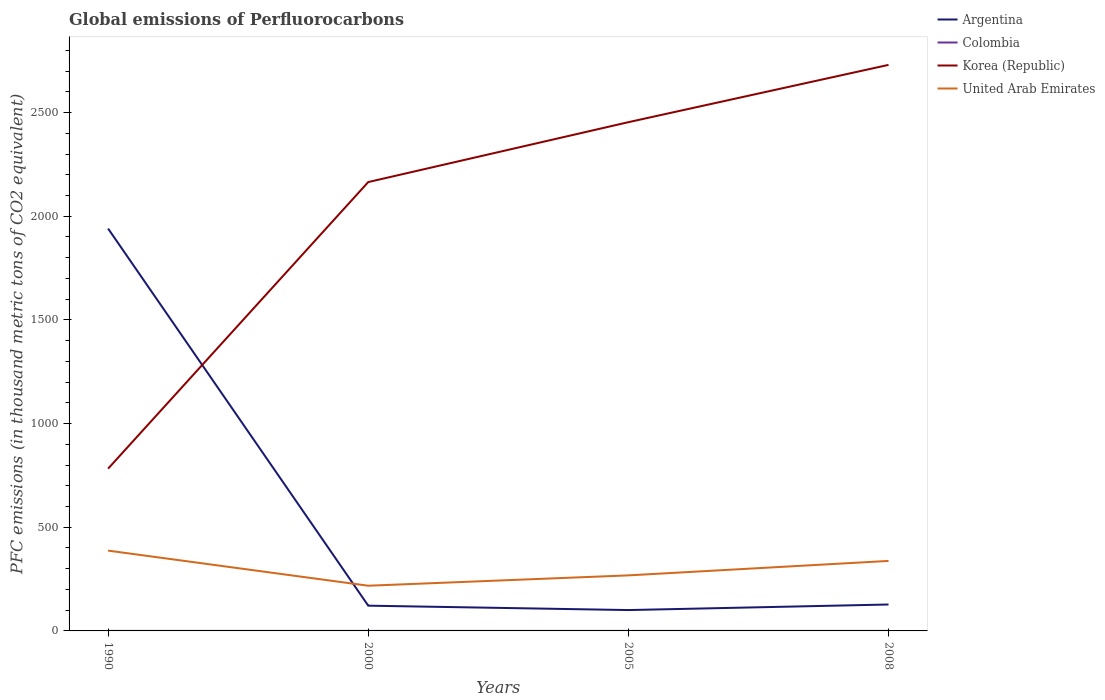Across all years, what is the maximum global emissions of Perfluorocarbons in Korea (Republic)?
Keep it short and to the point. 782.6. In which year was the global emissions of Perfluorocarbons in Korea (Republic) maximum?
Give a very brief answer. 1990. What is the total global emissions of Perfluorocarbons in Argentina in the graph?
Provide a succinct answer. 1818.8. What is the difference between the highest and the second highest global emissions of Perfluorocarbons in United Arab Emirates?
Offer a terse response. 169.3. Is the global emissions of Perfluorocarbons in Korea (Republic) strictly greater than the global emissions of Perfluorocarbons in United Arab Emirates over the years?
Keep it short and to the point. No. Are the values on the major ticks of Y-axis written in scientific E-notation?
Ensure brevity in your answer.  No. Does the graph contain any zero values?
Your answer should be very brief. No. What is the title of the graph?
Provide a succinct answer. Global emissions of Perfluorocarbons. What is the label or title of the X-axis?
Give a very brief answer. Years. What is the label or title of the Y-axis?
Your answer should be compact. PFC emissions (in thousand metric tons of CO2 equivalent). What is the PFC emissions (in thousand metric tons of CO2 equivalent) in Argentina in 1990?
Your response must be concise. 1940.6. What is the PFC emissions (in thousand metric tons of CO2 equivalent) of Colombia in 1990?
Give a very brief answer. 0.2. What is the PFC emissions (in thousand metric tons of CO2 equivalent) in Korea (Republic) in 1990?
Keep it short and to the point. 782.6. What is the PFC emissions (in thousand metric tons of CO2 equivalent) of United Arab Emirates in 1990?
Your response must be concise. 387.3. What is the PFC emissions (in thousand metric tons of CO2 equivalent) in Argentina in 2000?
Your response must be concise. 121.8. What is the PFC emissions (in thousand metric tons of CO2 equivalent) in Colombia in 2000?
Make the answer very short. 0.2. What is the PFC emissions (in thousand metric tons of CO2 equivalent) of Korea (Republic) in 2000?
Your response must be concise. 2164.9. What is the PFC emissions (in thousand metric tons of CO2 equivalent) of United Arab Emirates in 2000?
Give a very brief answer. 218. What is the PFC emissions (in thousand metric tons of CO2 equivalent) in Argentina in 2005?
Ensure brevity in your answer.  100.6. What is the PFC emissions (in thousand metric tons of CO2 equivalent) of Colombia in 2005?
Make the answer very short. 0.2. What is the PFC emissions (in thousand metric tons of CO2 equivalent) of Korea (Republic) in 2005?
Make the answer very short. 2453.7. What is the PFC emissions (in thousand metric tons of CO2 equivalent) of United Arab Emirates in 2005?
Keep it short and to the point. 267.9. What is the PFC emissions (in thousand metric tons of CO2 equivalent) in Argentina in 2008?
Offer a very short reply. 127.4. What is the PFC emissions (in thousand metric tons of CO2 equivalent) in Korea (Republic) in 2008?
Make the answer very short. 2730.1. What is the PFC emissions (in thousand metric tons of CO2 equivalent) of United Arab Emirates in 2008?
Provide a succinct answer. 337.6. Across all years, what is the maximum PFC emissions (in thousand metric tons of CO2 equivalent) in Argentina?
Provide a short and direct response. 1940.6. Across all years, what is the maximum PFC emissions (in thousand metric tons of CO2 equivalent) of Colombia?
Provide a short and direct response. 0.2. Across all years, what is the maximum PFC emissions (in thousand metric tons of CO2 equivalent) of Korea (Republic)?
Provide a short and direct response. 2730.1. Across all years, what is the maximum PFC emissions (in thousand metric tons of CO2 equivalent) of United Arab Emirates?
Offer a terse response. 387.3. Across all years, what is the minimum PFC emissions (in thousand metric tons of CO2 equivalent) of Argentina?
Your answer should be compact. 100.6. Across all years, what is the minimum PFC emissions (in thousand metric tons of CO2 equivalent) in Colombia?
Ensure brevity in your answer.  0.2. Across all years, what is the minimum PFC emissions (in thousand metric tons of CO2 equivalent) in Korea (Republic)?
Offer a very short reply. 782.6. Across all years, what is the minimum PFC emissions (in thousand metric tons of CO2 equivalent) of United Arab Emirates?
Make the answer very short. 218. What is the total PFC emissions (in thousand metric tons of CO2 equivalent) in Argentina in the graph?
Your answer should be compact. 2290.4. What is the total PFC emissions (in thousand metric tons of CO2 equivalent) in Colombia in the graph?
Offer a very short reply. 0.8. What is the total PFC emissions (in thousand metric tons of CO2 equivalent) in Korea (Republic) in the graph?
Keep it short and to the point. 8131.3. What is the total PFC emissions (in thousand metric tons of CO2 equivalent) of United Arab Emirates in the graph?
Your response must be concise. 1210.8. What is the difference between the PFC emissions (in thousand metric tons of CO2 equivalent) in Argentina in 1990 and that in 2000?
Your response must be concise. 1818.8. What is the difference between the PFC emissions (in thousand metric tons of CO2 equivalent) in Colombia in 1990 and that in 2000?
Offer a very short reply. 0. What is the difference between the PFC emissions (in thousand metric tons of CO2 equivalent) in Korea (Republic) in 1990 and that in 2000?
Your response must be concise. -1382.3. What is the difference between the PFC emissions (in thousand metric tons of CO2 equivalent) in United Arab Emirates in 1990 and that in 2000?
Provide a succinct answer. 169.3. What is the difference between the PFC emissions (in thousand metric tons of CO2 equivalent) of Argentina in 1990 and that in 2005?
Your response must be concise. 1840. What is the difference between the PFC emissions (in thousand metric tons of CO2 equivalent) of Korea (Republic) in 1990 and that in 2005?
Give a very brief answer. -1671.1. What is the difference between the PFC emissions (in thousand metric tons of CO2 equivalent) of United Arab Emirates in 1990 and that in 2005?
Offer a very short reply. 119.4. What is the difference between the PFC emissions (in thousand metric tons of CO2 equivalent) in Argentina in 1990 and that in 2008?
Ensure brevity in your answer.  1813.2. What is the difference between the PFC emissions (in thousand metric tons of CO2 equivalent) in Korea (Republic) in 1990 and that in 2008?
Your answer should be compact. -1947.5. What is the difference between the PFC emissions (in thousand metric tons of CO2 equivalent) of United Arab Emirates in 1990 and that in 2008?
Keep it short and to the point. 49.7. What is the difference between the PFC emissions (in thousand metric tons of CO2 equivalent) of Argentina in 2000 and that in 2005?
Your answer should be very brief. 21.2. What is the difference between the PFC emissions (in thousand metric tons of CO2 equivalent) in Korea (Republic) in 2000 and that in 2005?
Give a very brief answer. -288.8. What is the difference between the PFC emissions (in thousand metric tons of CO2 equivalent) in United Arab Emirates in 2000 and that in 2005?
Keep it short and to the point. -49.9. What is the difference between the PFC emissions (in thousand metric tons of CO2 equivalent) in Colombia in 2000 and that in 2008?
Provide a succinct answer. 0. What is the difference between the PFC emissions (in thousand metric tons of CO2 equivalent) of Korea (Republic) in 2000 and that in 2008?
Keep it short and to the point. -565.2. What is the difference between the PFC emissions (in thousand metric tons of CO2 equivalent) in United Arab Emirates in 2000 and that in 2008?
Make the answer very short. -119.6. What is the difference between the PFC emissions (in thousand metric tons of CO2 equivalent) of Argentina in 2005 and that in 2008?
Provide a succinct answer. -26.8. What is the difference between the PFC emissions (in thousand metric tons of CO2 equivalent) in Colombia in 2005 and that in 2008?
Provide a short and direct response. 0. What is the difference between the PFC emissions (in thousand metric tons of CO2 equivalent) in Korea (Republic) in 2005 and that in 2008?
Offer a very short reply. -276.4. What is the difference between the PFC emissions (in thousand metric tons of CO2 equivalent) of United Arab Emirates in 2005 and that in 2008?
Keep it short and to the point. -69.7. What is the difference between the PFC emissions (in thousand metric tons of CO2 equivalent) of Argentina in 1990 and the PFC emissions (in thousand metric tons of CO2 equivalent) of Colombia in 2000?
Your answer should be very brief. 1940.4. What is the difference between the PFC emissions (in thousand metric tons of CO2 equivalent) of Argentina in 1990 and the PFC emissions (in thousand metric tons of CO2 equivalent) of Korea (Republic) in 2000?
Your response must be concise. -224.3. What is the difference between the PFC emissions (in thousand metric tons of CO2 equivalent) in Argentina in 1990 and the PFC emissions (in thousand metric tons of CO2 equivalent) in United Arab Emirates in 2000?
Your response must be concise. 1722.6. What is the difference between the PFC emissions (in thousand metric tons of CO2 equivalent) of Colombia in 1990 and the PFC emissions (in thousand metric tons of CO2 equivalent) of Korea (Republic) in 2000?
Ensure brevity in your answer.  -2164.7. What is the difference between the PFC emissions (in thousand metric tons of CO2 equivalent) of Colombia in 1990 and the PFC emissions (in thousand metric tons of CO2 equivalent) of United Arab Emirates in 2000?
Provide a succinct answer. -217.8. What is the difference between the PFC emissions (in thousand metric tons of CO2 equivalent) in Korea (Republic) in 1990 and the PFC emissions (in thousand metric tons of CO2 equivalent) in United Arab Emirates in 2000?
Give a very brief answer. 564.6. What is the difference between the PFC emissions (in thousand metric tons of CO2 equivalent) of Argentina in 1990 and the PFC emissions (in thousand metric tons of CO2 equivalent) of Colombia in 2005?
Keep it short and to the point. 1940.4. What is the difference between the PFC emissions (in thousand metric tons of CO2 equivalent) of Argentina in 1990 and the PFC emissions (in thousand metric tons of CO2 equivalent) of Korea (Republic) in 2005?
Ensure brevity in your answer.  -513.1. What is the difference between the PFC emissions (in thousand metric tons of CO2 equivalent) in Argentina in 1990 and the PFC emissions (in thousand metric tons of CO2 equivalent) in United Arab Emirates in 2005?
Offer a very short reply. 1672.7. What is the difference between the PFC emissions (in thousand metric tons of CO2 equivalent) of Colombia in 1990 and the PFC emissions (in thousand metric tons of CO2 equivalent) of Korea (Republic) in 2005?
Provide a short and direct response. -2453.5. What is the difference between the PFC emissions (in thousand metric tons of CO2 equivalent) in Colombia in 1990 and the PFC emissions (in thousand metric tons of CO2 equivalent) in United Arab Emirates in 2005?
Your answer should be compact. -267.7. What is the difference between the PFC emissions (in thousand metric tons of CO2 equivalent) in Korea (Republic) in 1990 and the PFC emissions (in thousand metric tons of CO2 equivalent) in United Arab Emirates in 2005?
Provide a short and direct response. 514.7. What is the difference between the PFC emissions (in thousand metric tons of CO2 equivalent) in Argentina in 1990 and the PFC emissions (in thousand metric tons of CO2 equivalent) in Colombia in 2008?
Offer a very short reply. 1940.4. What is the difference between the PFC emissions (in thousand metric tons of CO2 equivalent) of Argentina in 1990 and the PFC emissions (in thousand metric tons of CO2 equivalent) of Korea (Republic) in 2008?
Ensure brevity in your answer.  -789.5. What is the difference between the PFC emissions (in thousand metric tons of CO2 equivalent) in Argentina in 1990 and the PFC emissions (in thousand metric tons of CO2 equivalent) in United Arab Emirates in 2008?
Offer a terse response. 1603. What is the difference between the PFC emissions (in thousand metric tons of CO2 equivalent) in Colombia in 1990 and the PFC emissions (in thousand metric tons of CO2 equivalent) in Korea (Republic) in 2008?
Your response must be concise. -2729.9. What is the difference between the PFC emissions (in thousand metric tons of CO2 equivalent) in Colombia in 1990 and the PFC emissions (in thousand metric tons of CO2 equivalent) in United Arab Emirates in 2008?
Offer a terse response. -337.4. What is the difference between the PFC emissions (in thousand metric tons of CO2 equivalent) in Korea (Republic) in 1990 and the PFC emissions (in thousand metric tons of CO2 equivalent) in United Arab Emirates in 2008?
Give a very brief answer. 445. What is the difference between the PFC emissions (in thousand metric tons of CO2 equivalent) of Argentina in 2000 and the PFC emissions (in thousand metric tons of CO2 equivalent) of Colombia in 2005?
Make the answer very short. 121.6. What is the difference between the PFC emissions (in thousand metric tons of CO2 equivalent) of Argentina in 2000 and the PFC emissions (in thousand metric tons of CO2 equivalent) of Korea (Republic) in 2005?
Offer a very short reply. -2331.9. What is the difference between the PFC emissions (in thousand metric tons of CO2 equivalent) in Argentina in 2000 and the PFC emissions (in thousand metric tons of CO2 equivalent) in United Arab Emirates in 2005?
Provide a short and direct response. -146.1. What is the difference between the PFC emissions (in thousand metric tons of CO2 equivalent) in Colombia in 2000 and the PFC emissions (in thousand metric tons of CO2 equivalent) in Korea (Republic) in 2005?
Your response must be concise. -2453.5. What is the difference between the PFC emissions (in thousand metric tons of CO2 equivalent) in Colombia in 2000 and the PFC emissions (in thousand metric tons of CO2 equivalent) in United Arab Emirates in 2005?
Offer a very short reply. -267.7. What is the difference between the PFC emissions (in thousand metric tons of CO2 equivalent) in Korea (Republic) in 2000 and the PFC emissions (in thousand metric tons of CO2 equivalent) in United Arab Emirates in 2005?
Give a very brief answer. 1897. What is the difference between the PFC emissions (in thousand metric tons of CO2 equivalent) in Argentina in 2000 and the PFC emissions (in thousand metric tons of CO2 equivalent) in Colombia in 2008?
Your answer should be compact. 121.6. What is the difference between the PFC emissions (in thousand metric tons of CO2 equivalent) of Argentina in 2000 and the PFC emissions (in thousand metric tons of CO2 equivalent) of Korea (Republic) in 2008?
Provide a succinct answer. -2608.3. What is the difference between the PFC emissions (in thousand metric tons of CO2 equivalent) in Argentina in 2000 and the PFC emissions (in thousand metric tons of CO2 equivalent) in United Arab Emirates in 2008?
Make the answer very short. -215.8. What is the difference between the PFC emissions (in thousand metric tons of CO2 equivalent) in Colombia in 2000 and the PFC emissions (in thousand metric tons of CO2 equivalent) in Korea (Republic) in 2008?
Provide a short and direct response. -2729.9. What is the difference between the PFC emissions (in thousand metric tons of CO2 equivalent) in Colombia in 2000 and the PFC emissions (in thousand metric tons of CO2 equivalent) in United Arab Emirates in 2008?
Make the answer very short. -337.4. What is the difference between the PFC emissions (in thousand metric tons of CO2 equivalent) in Korea (Republic) in 2000 and the PFC emissions (in thousand metric tons of CO2 equivalent) in United Arab Emirates in 2008?
Provide a succinct answer. 1827.3. What is the difference between the PFC emissions (in thousand metric tons of CO2 equivalent) in Argentina in 2005 and the PFC emissions (in thousand metric tons of CO2 equivalent) in Colombia in 2008?
Provide a succinct answer. 100.4. What is the difference between the PFC emissions (in thousand metric tons of CO2 equivalent) in Argentina in 2005 and the PFC emissions (in thousand metric tons of CO2 equivalent) in Korea (Republic) in 2008?
Offer a terse response. -2629.5. What is the difference between the PFC emissions (in thousand metric tons of CO2 equivalent) of Argentina in 2005 and the PFC emissions (in thousand metric tons of CO2 equivalent) of United Arab Emirates in 2008?
Offer a terse response. -237. What is the difference between the PFC emissions (in thousand metric tons of CO2 equivalent) in Colombia in 2005 and the PFC emissions (in thousand metric tons of CO2 equivalent) in Korea (Republic) in 2008?
Make the answer very short. -2729.9. What is the difference between the PFC emissions (in thousand metric tons of CO2 equivalent) of Colombia in 2005 and the PFC emissions (in thousand metric tons of CO2 equivalent) of United Arab Emirates in 2008?
Your response must be concise. -337.4. What is the difference between the PFC emissions (in thousand metric tons of CO2 equivalent) of Korea (Republic) in 2005 and the PFC emissions (in thousand metric tons of CO2 equivalent) of United Arab Emirates in 2008?
Your response must be concise. 2116.1. What is the average PFC emissions (in thousand metric tons of CO2 equivalent) in Argentina per year?
Provide a succinct answer. 572.6. What is the average PFC emissions (in thousand metric tons of CO2 equivalent) of Colombia per year?
Ensure brevity in your answer.  0.2. What is the average PFC emissions (in thousand metric tons of CO2 equivalent) in Korea (Republic) per year?
Make the answer very short. 2032.83. What is the average PFC emissions (in thousand metric tons of CO2 equivalent) of United Arab Emirates per year?
Provide a succinct answer. 302.7. In the year 1990, what is the difference between the PFC emissions (in thousand metric tons of CO2 equivalent) in Argentina and PFC emissions (in thousand metric tons of CO2 equivalent) in Colombia?
Give a very brief answer. 1940.4. In the year 1990, what is the difference between the PFC emissions (in thousand metric tons of CO2 equivalent) in Argentina and PFC emissions (in thousand metric tons of CO2 equivalent) in Korea (Republic)?
Provide a short and direct response. 1158. In the year 1990, what is the difference between the PFC emissions (in thousand metric tons of CO2 equivalent) of Argentina and PFC emissions (in thousand metric tons of CO2 equivalent) of United Arab Emirates?
Make the answer very short. 1553.3. In the year 1990, what is the difference between the PFC emissions (in thousand metric tons of CO2 equivalent) of Colombia and PFC emissions (in thousand metric tons of CO2 equivalent) of Korea (Republic)?
Offer a very short reply. -782.4. In the year 1990, what is the difference between the PFC emissions (in thousand metric tons of CO2 equivalent) in Colombia and PFC emissions (in thousand metric tons of CO2 equivalent) in United Arab Emirates?
Make the answer very short. -387.1. In the year 1990, what is the difference between the PFC emissions (in thousand metric tons of CO2 equivalent) in Korea (Republic) and PFC emissions (in thousand metric tons of CO2 equivalent) in United Arab Emirates?
Your response must be concise. 395.3. In the year 2000, what is the difference between the PFC emissions (in thousand metric tons of CO2 equivalent) of Argentina and PFC emissions (in thousand metric tons of CO2 equivalent) of Colombia?
Your response must be concise. 121.6. In the year 2000, what is the difference between the PFC emissions (in thousand metric tons of CO2 equivalent) in Argentina and PFC emissions (in thousand metric tons of CO2 equivalent) in Korea (Republic)?
Provide a short and direct response. -2043.1. In the year 2000, what is the difference between the PFC emissions (in thousand metric tons of CO2 equivalent) in Argentina and PFC emissions (in thousand metric tons of CO2 equivalent) in United Arab Emirates?
Keep it short and to the point. -96.2. In the year 2000, what is the difference between the PFC emissions (in thousand metric tons of CO2 equivalent) of Colombia and PFC emissions (in thousand metric tons of CO2 equivalent) of Korea (Republic)?
Make the answer very short. -2164.7. In the year 2000, what is the difference between the PFC emissions (in thousand metric tons of CO2 equivalent) of Colombia and PFC emissions (in thousand metric tons of CO2 equivalent) of United Arab Emirates?
Make the answer very short. -217.8. In the year 2000, what is the difference between the PFC emissions (in thousand metric tons of CO2 equivalent) in Korea (Republic) and PFC emissions (in thousand metric tons of CO2 equivalent) in United Arab Emirates?
Offer a very short reply. 1946.9. In the year 2005, what is the difference between the PFC emissions (in thousand metric tons of CO2 equivalent) of Argentina and PFC emissions (in thousand metric tons of CO2 equivalent) of Colombia?
Your response must be concise. 100.4. In the year 2005, what is the difference between the PFC emissions (in thousand metric tons of CO2 equivalent) of Argentina and PFC emissions (in thousand metric tons of CO2 equivalent) of Korea (Republic)?
Offer a terse response. -2353.1. In the year 2005, what is the difference between the PFC emissions (in thousand metric tons of CO2 equivalent) of Argentina and PFC emissions (in thousand metric tons of CO2 equivalent) of United Arab Emirates?
Give a very brief answer. -167.3. In the year 2005, what is the difference between the PFC emissions (in thousand metric tons of CO2 equivalent) of Colombia and PFC emissions (in thousand metric tons of CO2 equivalent) of Korea (Republic)?
Your response must be concise. -2453.5. In the year 2005, what is the difference between the PFC emissions (in thousand metric tons of CO2 equivalent) of Colombia and PFC emissions (in thousand metric tons of CO2 equivalent) of United Arab Emirates?
Your response must be concise. -267.7. In the year 2005, what is the difference between the PFC emissions (in thousand metric tons of CO2 equivalent) in Korea (Republic) and PFC emissions (in thousand metric tons of CO2 equivalent) in United Arab Emirates?
Give a very brief answer. 2185.8. In the year 2008, what is the difference between the PFC emissions (in thousand metric tons of CO2 equivalent) of Argentina and PFC emissions (in thousand metric tons of CO2 equivalent) of Colombia?
Your answer should be very brief. 127.2. In the year 2008, what is the difference between the PFC emissions (in thousand metric tons of CO2 equivalent) of Argentina and PFC emissions (in thousand metric tons of CO2 equivalent) of Korea (Republic)?
Ensure brevity in your answer.  -2602.7. In the year 2008, what is the difference between the PFC emissions (in thousand metric tons of CO2 equivalent) in Argentina and PFC emissions (in thousand metric tons of CO2 equivalent) in United Arab Emirates?
Provide a succinct answer. -210.2. In the year 2008, what is the difference between the PFC emissions (in thousand metric tons of CO2 equivalent) of Colombia and PFC emissions (in thousand metric tons of CO2 equivalent) of Korea (Republic)?
Provide a succinct answer. -2729.9. In the year 2008, what is the difference between the PFC emissions (in thousand metric tons of CO2 equivalent) in Colombia and PFC emissions (in thousand metric tons of CO2 equivalent) in United Arab Emirates?
Provide a succinct answer. -337.4. In the year 2008, what is the difference between the PFC emissions (in thousand metric tons of CO2 equivalent) of Korea (Republic) and PFC emissions (in thousand metric tons of CO2 equivalent) of United Arab Emirates?
Your response must be concise. 2392.5. What is the ratio of the PFC emissions (in thousand metric tons of CO2 equivalent) in Argentina in 1990 to that in 2000?
Provide a succinct answer. 15.93. What is the ratio of the PFC emissions (in thousand metric tons of CO2 equivalent) of Colombia in 1990 to that in 2000?
Ensure brevity in your answer.  1. What is the ratio of the PFC emissions (in thousand metric tons of CO2 equivalent) in Korea (Republic) in 1990 to that in 2000?
Your response must be concise. 0.36. What is the ratio of the PFC emissions (in thousand metric tons of CO2 equivalent) of United Arab Emirates in 1990 to that in 2000?
Provide a succinct answer. 1.78. What is the ratio of the PFC emissions (in thousand metric tons of CO2 equivalent) in Argentina in 1990 to that in 2005?
Keep it short and to the point. 19.29. What is the ratio of the PFC emissions (in thousand metric tons of CO2 equivalent) of Colombia in 1990 to that in 2005?
Your answer should be very brief. 1. What is the ratio of the PFC emissions (in thousand metric tons of CO2 equivalent) of Korea (Republic) in 1990 to that in 2005?
Your answer should be compact. 0.32. What is the ratio of the PFC emissions (in thousand metric tons of CO2 equivalent) in United Arab Emirates in 1990 to that in 2005?
Your response must be concise. 1.45. What is the ratio of the PFC emissions (in thousand metric tons of CO2 equivalent) in Argentina in 1990 to that in 2008?
Make the answer very short. 15.23. What is the ratio of the PFC emissions (in thousand metric tons of CO2 equivalent) in Korea (Republic) in 1990 to that in 2008?
Provide a short and direct response. 0.29. What is the ratio of the PFC emissions (in thousand metric tons of CO2 equivalent) of United Arab Emirates in 1990 to that in 2008?
Your response must be concise. 1.15. What is the ratio of the PFC emissions (in thousand metric tons of CO2 equivalent) of Argentina in 2000 to that in 2005?
Offer a very short reply. 1.21. What is the ratio of the PFC emissions (in thousand metric tons of CO2 equivalent) of Colombia in 2000 to that in 2005?
Make the answer very short. 1. What is the ratio of the PFC emissions (in thousand metric tons of CO2 equivalent) in Korea (Republic) in 2000 to that in 2005?
Offer a terse response. 0.88. What is the ratio of the PFC emissions (in thousand metric tons of CO2 equivalent) in United Arab Emirates in 2000 to that in 2005?
Provide a succinct answer. 0.81. What is the ratio of the PFC emissions (in thousand metric tons of CO2 equivalent) in Argentina in 2000 to that in 2008?
Provide a short and direct response. 0.96. What is the ratio of the PFC emissions (in thousand metric tons of CO2 equivalent) of Colombia in 2000 to that in 2008?
Give a very brief answer. 1. What is the ratio of the PFC emissions (in thousand metric tons of CO2 equivalent) of Korea (Republic) in 2000 to that in 2008?
Make the answer very short. 0.79. What is the ratio of the PFC emissions (in thousand metric tons of CO2 equivalent) of United Arab Emirates in 2000 to that in 2008?
Your answer should be compact. 0.65. What is the ratio of the PFC emissions (in thousand metric tons of CO2 equivalent) in Argentina in 2005 to that in 2008?
Keep it short and to the point. 0.79. What is the ratio of the PFC emissions (in thousand metric tons of CO2 equivalent) of Korea (Republic) in 2005 to that in 2008?
Provide a succinct answer. 0.9. What is the ratio of the PFC emissions (in thousand metric tons of CO2 equivalent) of United Arab Emirates in 2005 to that in 2008?
Your response must be concise. 0.79. What is the difference between the highest and the second highest PFC emissions (in thousand metric tons of CO2 equivalent) of Argentina?
Your answer should be very brief. 1813.2. What is the difference between the highest and the second highest PFC emissions (in thousand metric tons of CO2 equivalent) of Colombia?
Ensure brevity in your answer.  0. What is the difference between the highest and the second highest PFC emissions (in thousand metric tons of CO2 equivalent) of Korea (Republic)?
Keep it short and to the point. 276.4. What is the difference between the highest and the second highest PFC emissions (in thousand metric tons of CO2 equivalent) of United Arab Emirates?
Provide a succinct answer. 49.7. What is the difference between the highest and the lowest PFC emissions (in thousand metric tons of CO2 equivalent) in Argentina?
Provide a short and direct response. 1840. What is the difference between the highest and the lowest PFC emissions (in thousand metric tons of CO2 equivalent) in Colombia?
Provide a short and direct response. 0. What is the difference between the highest and the lowest PFC emissions (in thousand metric tons of CO2 equivalent) of Korea (Republic)?
Give a very brief answer. 1947.5. What is the difference between the highest and the lowest PFC emissions (in thousand metric tons of CO2 equivalent) of United Arab Emirates?
Offer a very short reply. 169.3. 